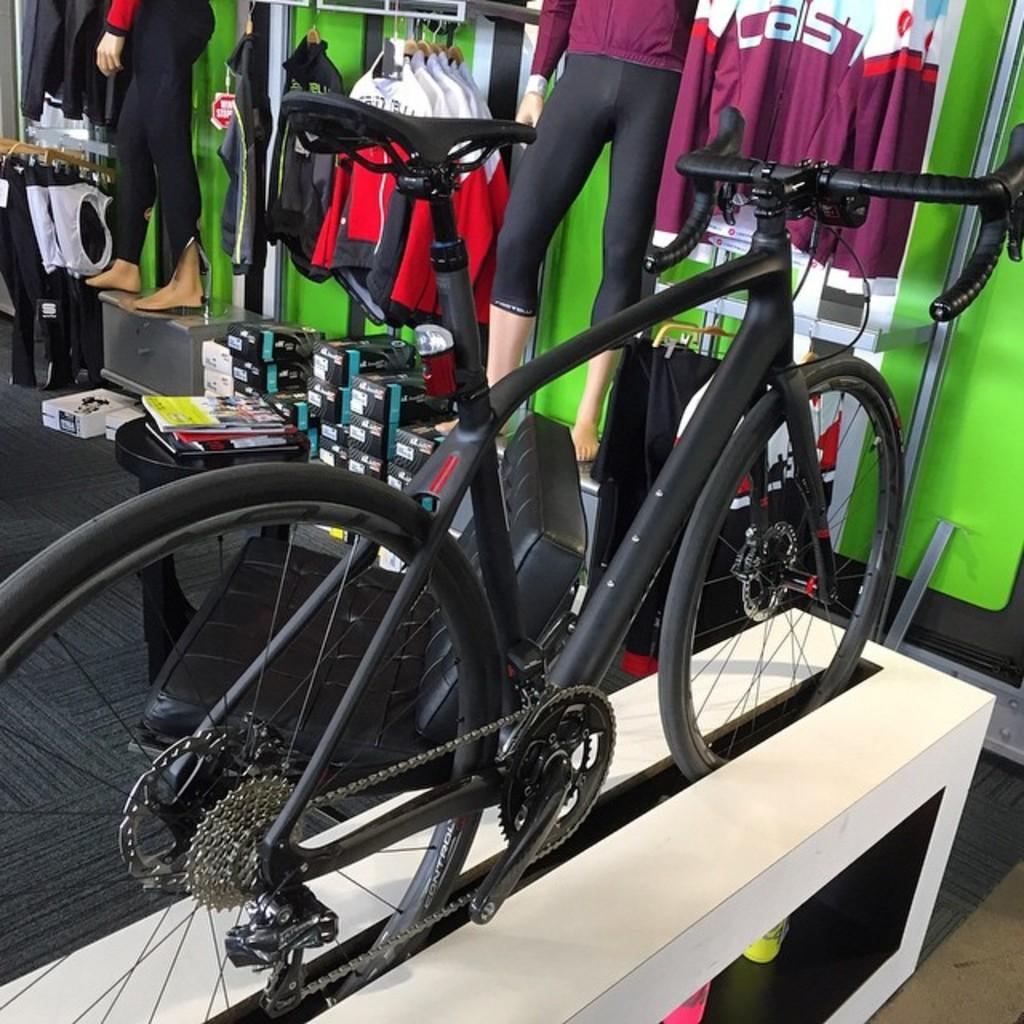What is the main object in the image? There is a bicycle in the image. What other items can be seen in the image? There are mannequins and jackets in the image. Can you describe the mannequins in the image? The mannequins are wearing jackets. What else can be seen in the image besides the bicycle, mannequins, and jackets? There are other unspecified objects in the image. What type of soup is being served in the image? There is no soup present in the image. How many strands of hair can be seen on the mannequins in the image? The mannequins in the image do not have hair, as they are not human beings. 